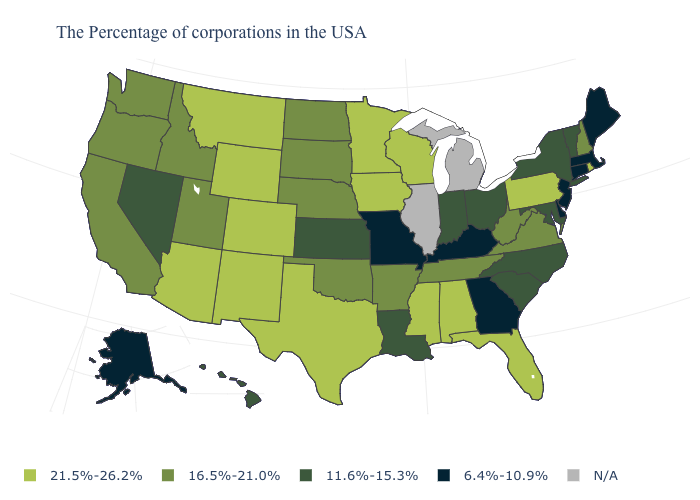What is the highest value in the USA?
Give a very brief answer. 21.5%-26.2%. Which states hav the highest value in the West?
Be succinct. Wyoming, Colorado, New Mexico, Montana, Arizona. Name the states that have a value in the range 6.4%-10.9%?
Be succinct. Maine, Massachusetts, Connecticut, New Jersey, Delaware, Georgia, Kentucky, Missouri, Alaska. Name the states that have a value in the range 11.6%-15.3%?
Give a very brief answer. Vermont, New York, Maryland, North Carolina, South Carolina, Ohio, Indiana, Louisiana, Kansas, Nevada, Hawaii. Does Idaho have the highest value in the USA?
Write a very short answer. No. What is the value of Minnesota?
Write a very short answer. 21.5%-26.2%. What is the lowest value in states that border Wyoming?
Give a very brief answer. 16.5%-21.0%. Which states have the highest value in the USA?
Answer briefly. Rhode Island, Pennsylvania, Florida, Alabama, Wisconsin, Mississippi, Minnesota, Iowa, Texas, Wyoming, Colorado, New Mexico, Montana, Arizona. What is the lowest value in the USA?
Give a very brief answer. 6.4%-10.9%. Name the states that have a value in the range 11.6%-15.3%?
Answer briefly. Vermont, New York, Maryland, North Carolina, South Carolina, Ohio, Indiana, Louisiana, Kansas, Nevada, Hawaii. What is the value of New Jersey?
Concise answer only. 6.4%-10.9%. Name the states that have a value in the range 16.5%-21.0%?
Answer briefly. New Hampshire, Virginia, West Virginia, Tennessee, Arkansas, Nebraska, Oklahoma, South Dakota, North Dakota, Utah, Idaho, California, Washington, Oregon. Does Missouri have the lowest value in the USA?
Give a very brief answer. Yes. Name the states that have a value in the range 21.5%-26.2%?
Keep it brief. Rhode Island, Pennsylvania, Florida, Alabama, Wisconsin, Mississippi, Minnesota, Iowa, Texas, Wyoming, Colorado, New Mexico, Montana, Arizona. Which states have the lowest value in the USA?
Keep it brief. Maine, Massachusetts, Connecticut, New Jersey, Delaware, Georgia, Kentucky, Missouri, Alaska. 